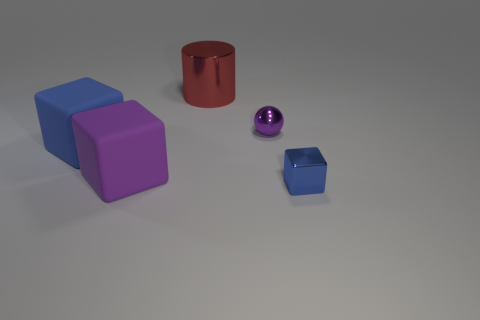Do the tiny blue shiny thing and the big purple matte thing have the same shape?
Ensure brevity in your answer.  Yes. Are there fewer red objects right of the big red cylinder than blue objects?
Make the answer very short. Yes. What is the color of the big matte block right of the blue object left of the big shiny thing to the left of the small blue cube?
Give a very brief answer. Purple. How many matte things are either yellow objects or purple cubes?
Provide a short and direct response. 1. Do the blue matte cube and the blue metallic thing have the same size?
Your response must be concise. No. Is the number of small purple things behind the purple shiny object less than the number of large red things that are right of the small blue metallic object?
Your answer should be compact. No. Are there any other things that are the same size as the metal cylinder?
Your answer should be very brief. Yes. How big is the blue metallic block?
Your response must be concise. Small. How many tiny things are either balls or cylinders?
Provide a succinct answer. 1. There is a metallic cylinder; does it have the same size as the blue shiny object in front of the red object?
Offer a very short reply. No. 